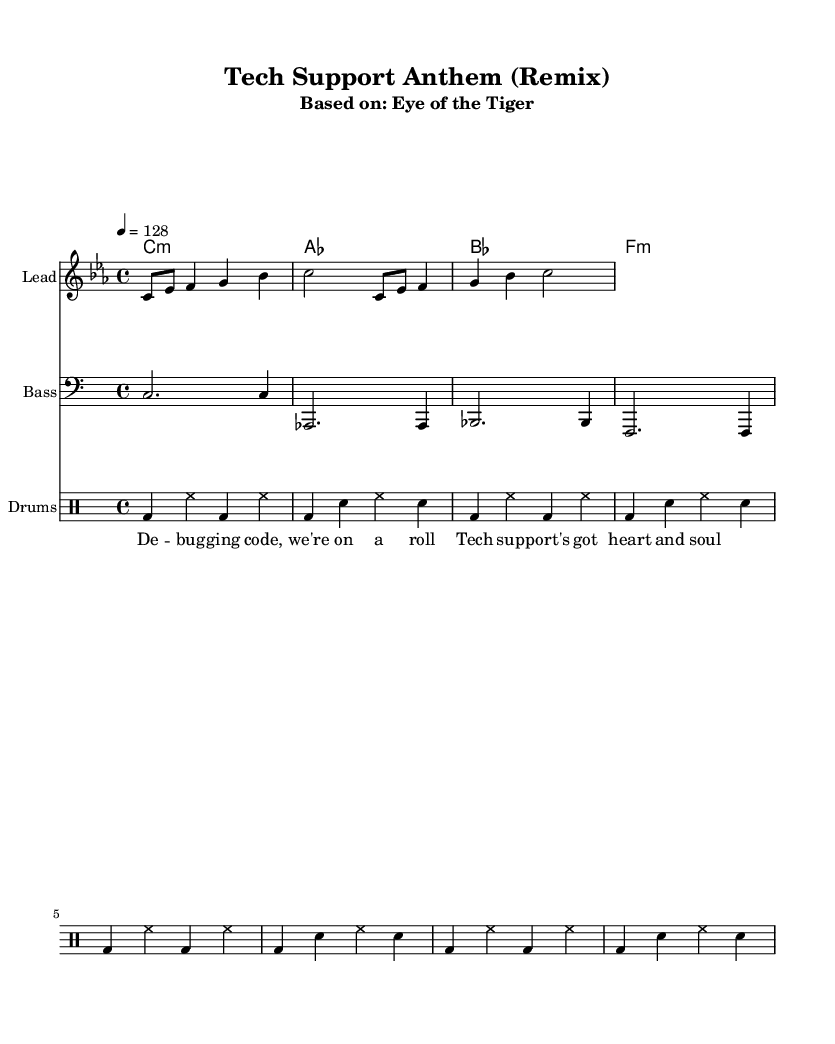What is the key signature of this music? The key signature is C minor, which has three flats in the key signature (B-flat, E-flat, A-flat). This can be identified by looking at the key indication at the beginning of the score.
Answer: C minor What is the time signature? The time signature is 4/4, which indicates that there are four beats in each measure and that the quarter note gets the beat. This is indicated at the beginning of the score right after the key signature.
Answer: 4/4 What is the tempo marking? The tempo marking is 128 beats per minute, indicated by the tempo marking at the start of the score. This tells us the speed at which the piece should be played, emphasizing an energetic feel.
Answer: 128 How many measures does the melody contain? The melody is written across four measures, which can be counted by observing the separation of the notes and the measure lines throughout the staff.
Answer: 4 What type of drum pattern is used? The drum pattern consists of a kick drum and hi-hat, alternating in a repetitive structure, which is a common element in house music to create a driving rhythm. This is identified by the notation in the drum staff.
Answer: Kick and hi-hat How many chords are listed in the harmonies section? There are four chords listed in the harmonies section: C minor, A-flat major, B-flat major, and F minor. Each chord is indicated in a single measure, noted together in the chord names section.
Answer: 4 What is the primary lyrical theme of the song? The lyrical theme focuses on technology and problem-solving, as indicated by the lyrics "Debugging code, we're on a roll" and "Tech support's got heart and soul." This conveys motivation during challenging tasks.
Answer: Technology 